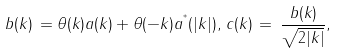Convert formula to latex. <formula><loc_0><loc_0><loc_500><loc_500>b ( k ) \, = \theta ( k ) a ( k ) + \theta ( - k ) a ^ { ^ { * } } ( | k | ) , \, c ( k ) \, = \, \frac { b ( k ) } { \sqrt { 2 | k | } } ,</formula> 